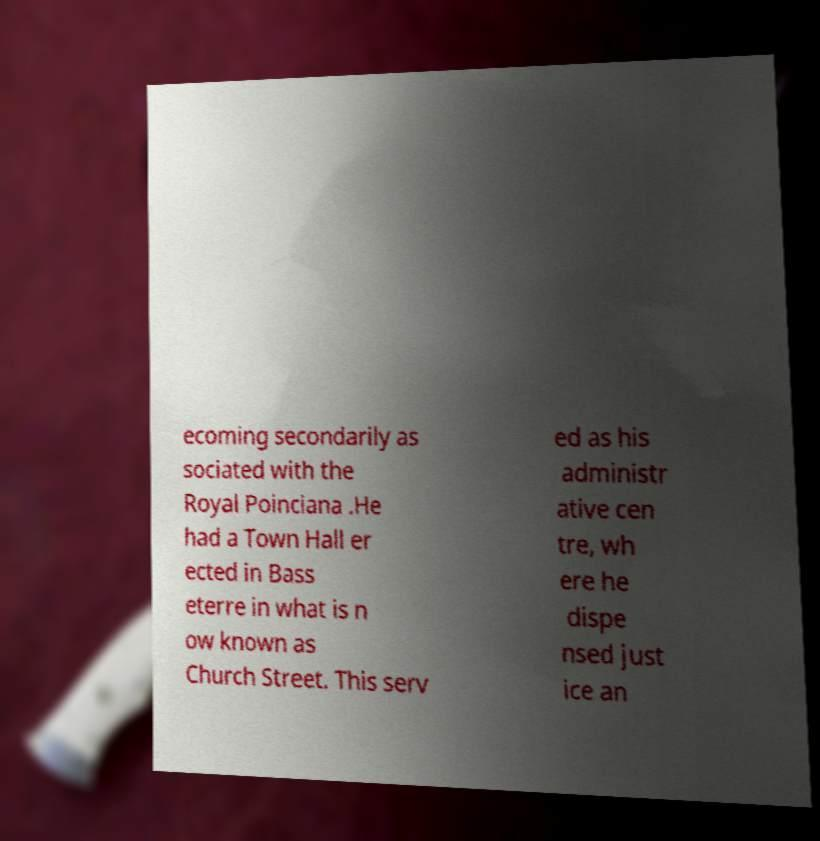Can you read and provide the text displayed in the image?This photo seems to have some interesting text. Can you extract and type it out for me? ecoming secondarily as sociated with the Royal Poinciana .He had a Town Hall er ected in Bass eterre in what is n ow known as Church Street. This serv ed as his administr ative cen tre, wh ere he dispe nsed just ice an 